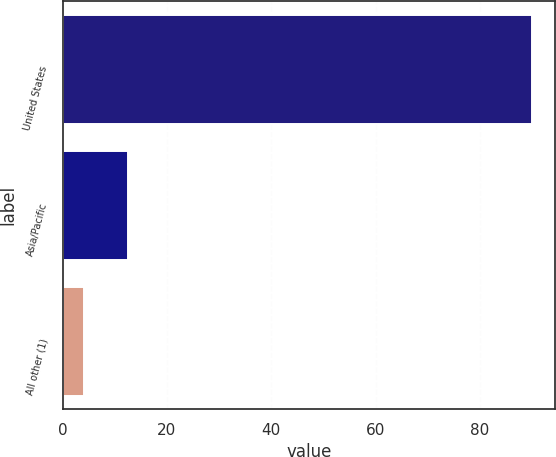Convert chart to OTSL. <chart><loc_0><loc_0><loc_500><loc_500><bar_chart><fcel>United States<fcel>Asia/Pacific<fcel>All other (1)<nl><fcel>90<fcel>12.6<fcel>4<nl></chart> 